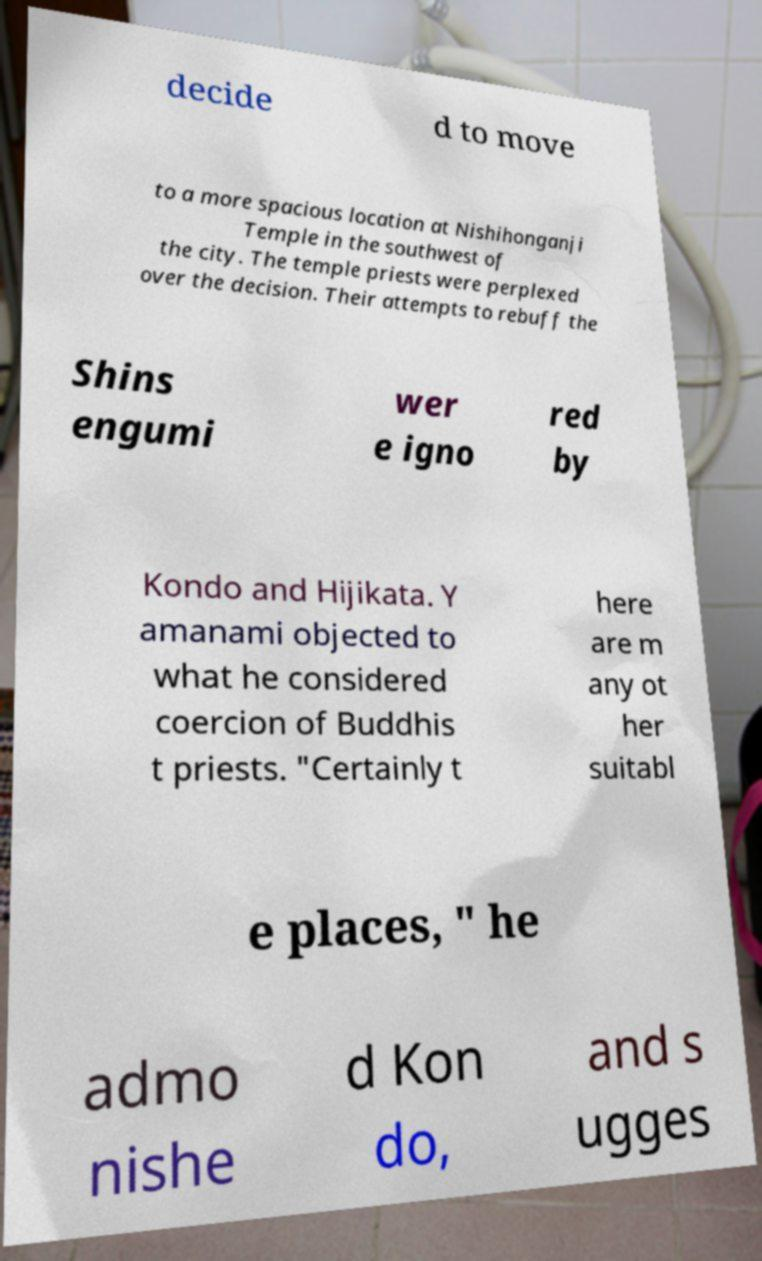Please read and relay the text visible in this image. What does it say? decide d to move to a more spacious location at Nishihonganji Temple in the southwest of the city. The temple priests were perplexed over the decision. Their attempts to rebuff the Shins engumi wer e igno red by Kondo and Hijikata. Y amanami objected to what he considered coercion of Buddhis t priests. "Certainly t here are m any ot her suitabl e places, " he admo nishe d Kon do, and s ugges 